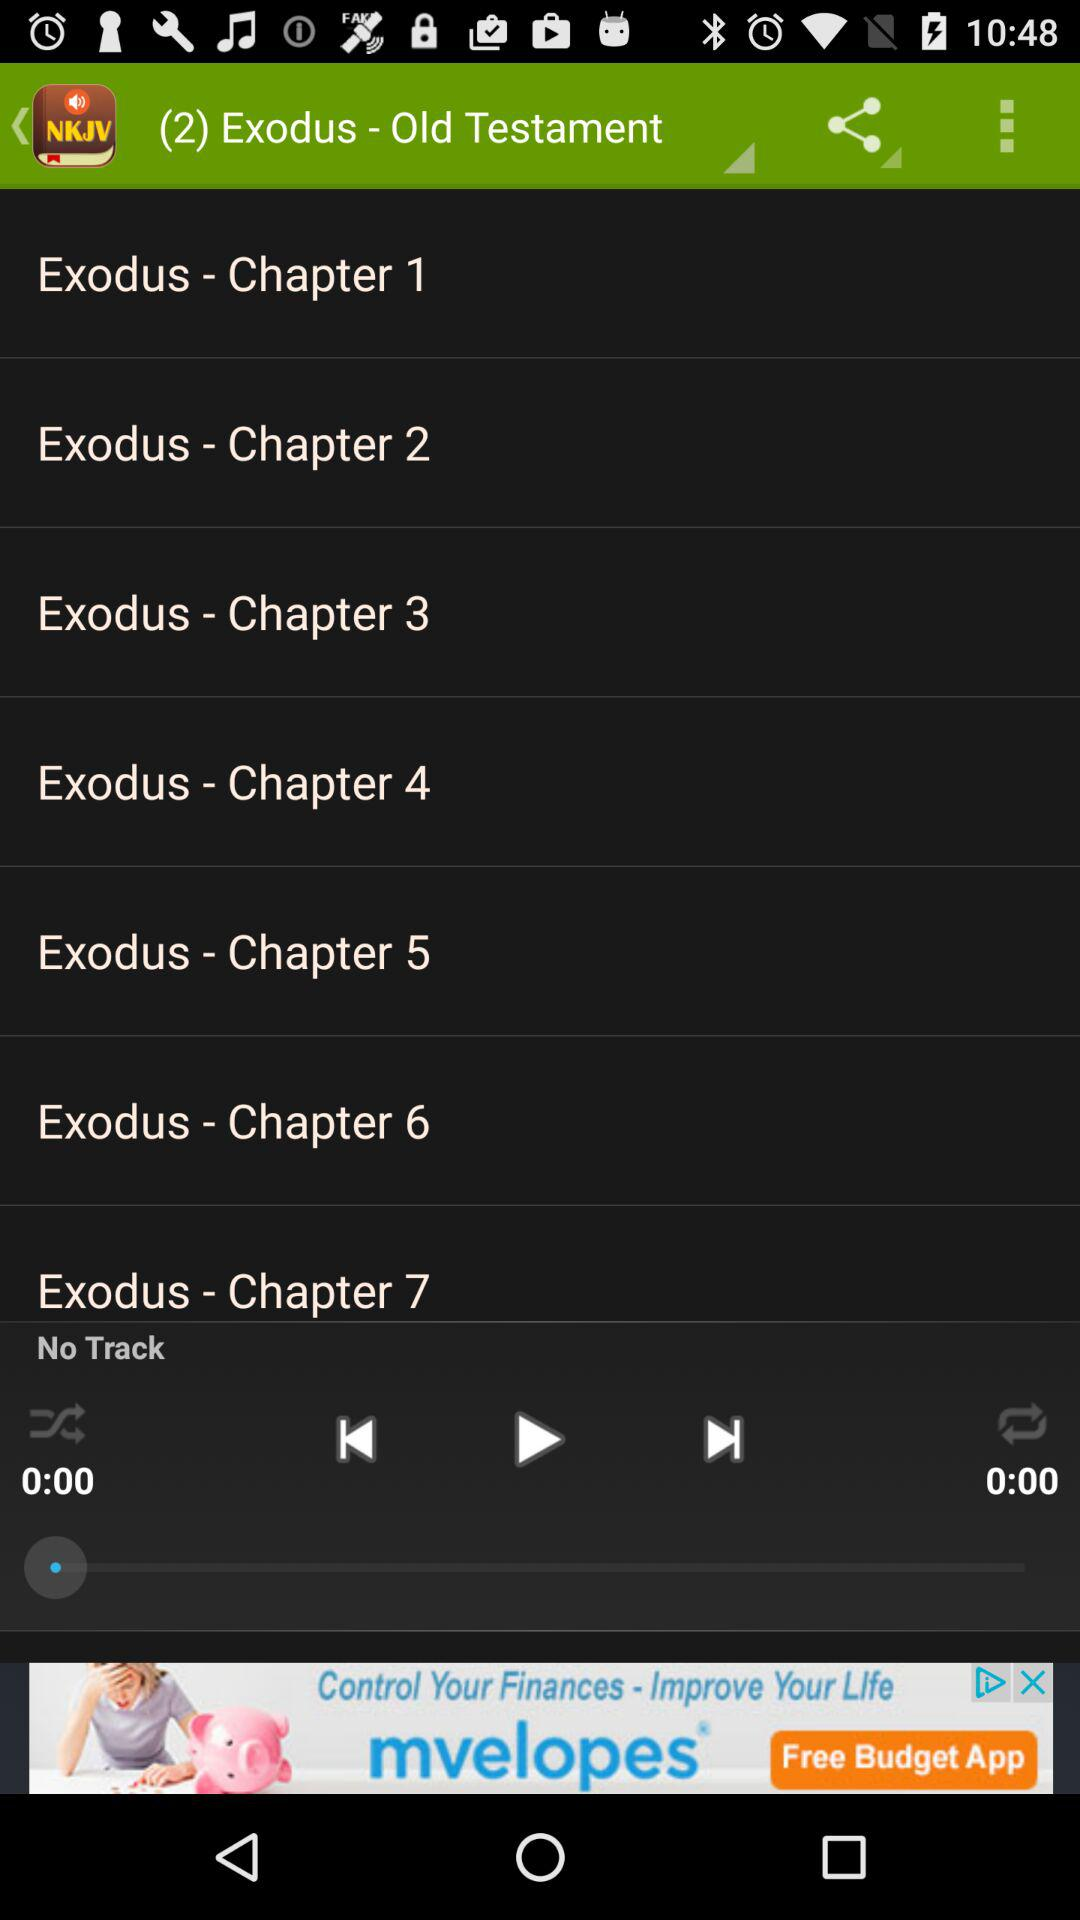How many chapters are there of Exodus?
Answer the question using a single word or phrase. 7 